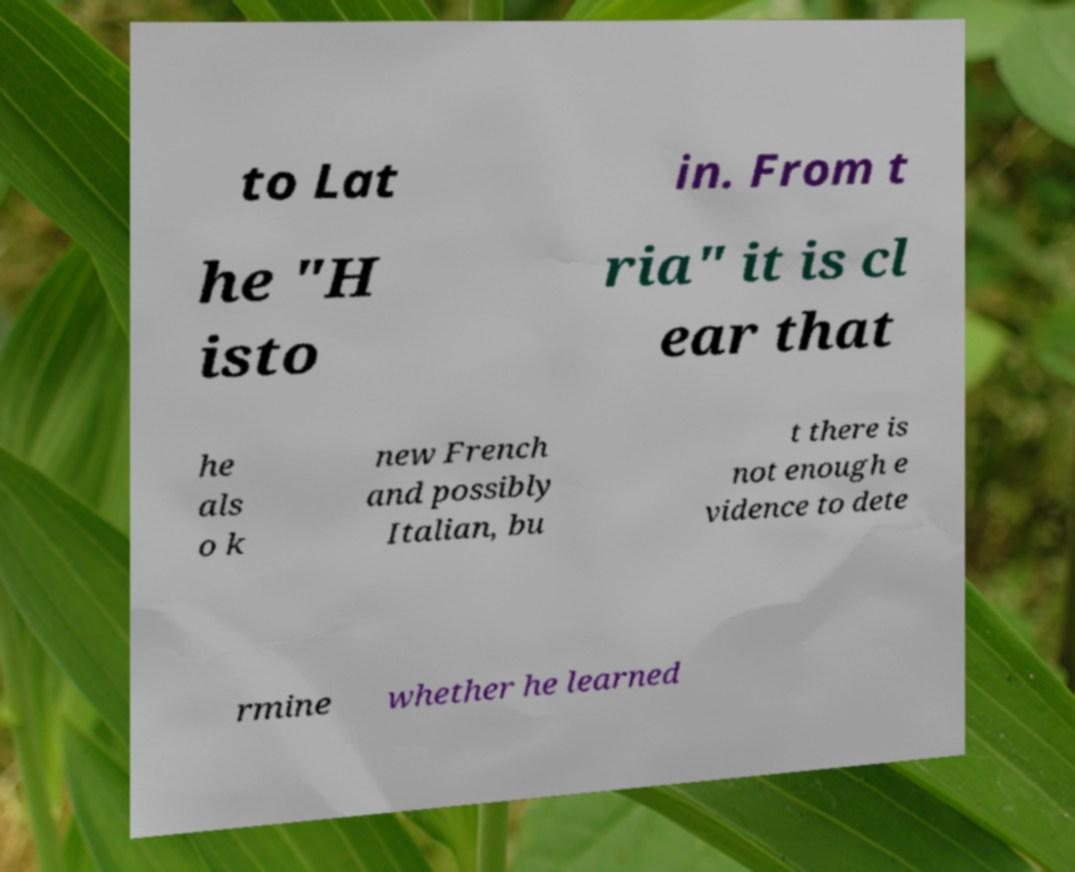Can you read and provide the text displayed in the image?This photo seems to have some interesting text. Can you extract and type it out for me? to Lat in. From t he "H isto ria" it is cl ear that he als o k new French and possibly Italian, bu t there is not enough e vidence to dete rmine whether he learned 